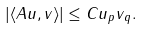<formula> <loc_0><loc_0><loc_500><loc_500>| \langle A u , v \rangle | \leq C \| u \| _ { p } \| v \| _ { q } .</formula> 